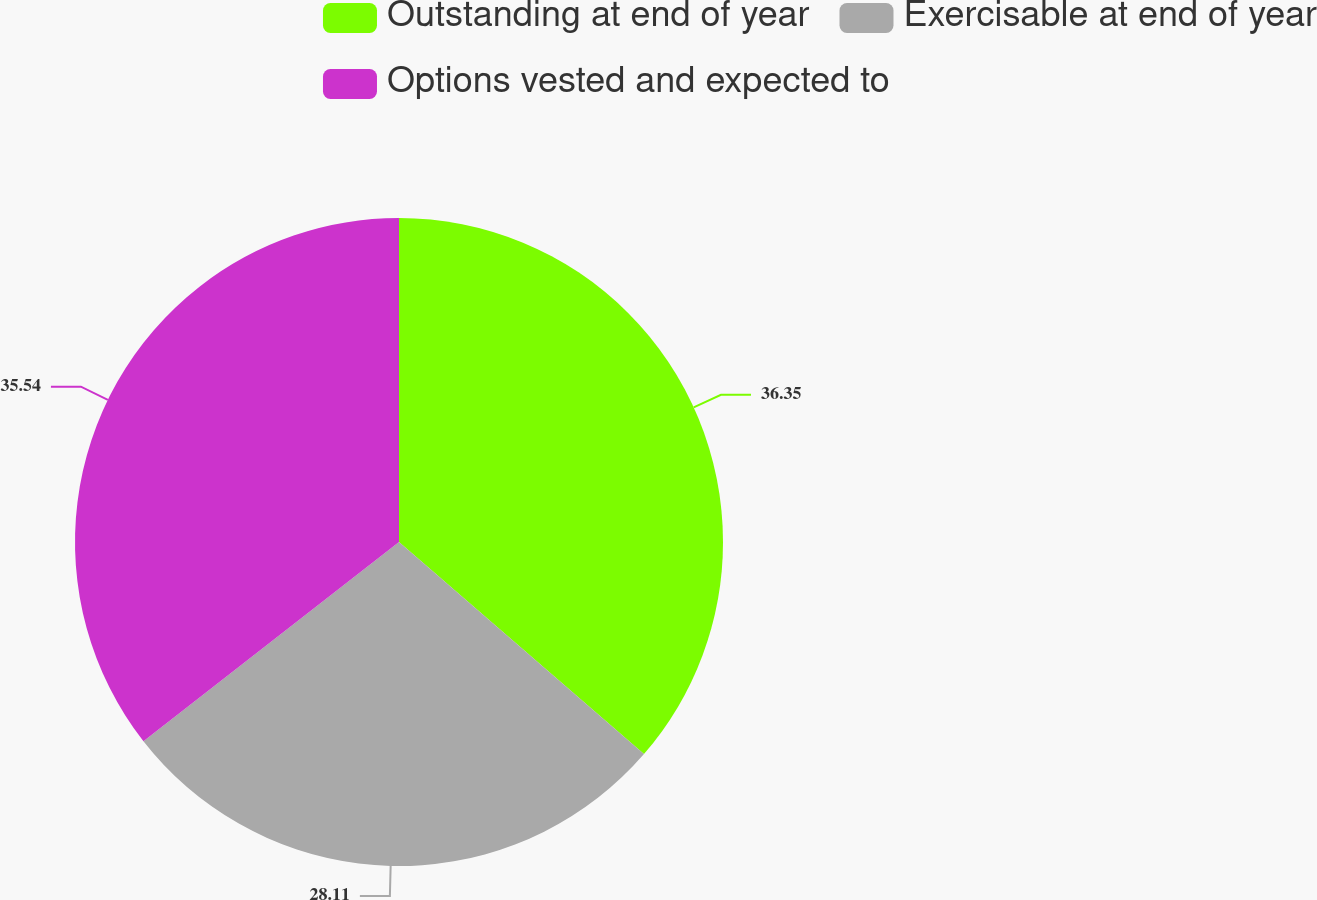Convert chart to OTSL. <chart><loc_0><loc_0><loc_500><loc_500><pie_chart><fcel>Outstanding at end of year<fcel>Exercisable at end of year<fcel>Options vested and expected to<nl><fcel>36.36%<fcel>28.11%<fcel>35.54%<nl></chart> 